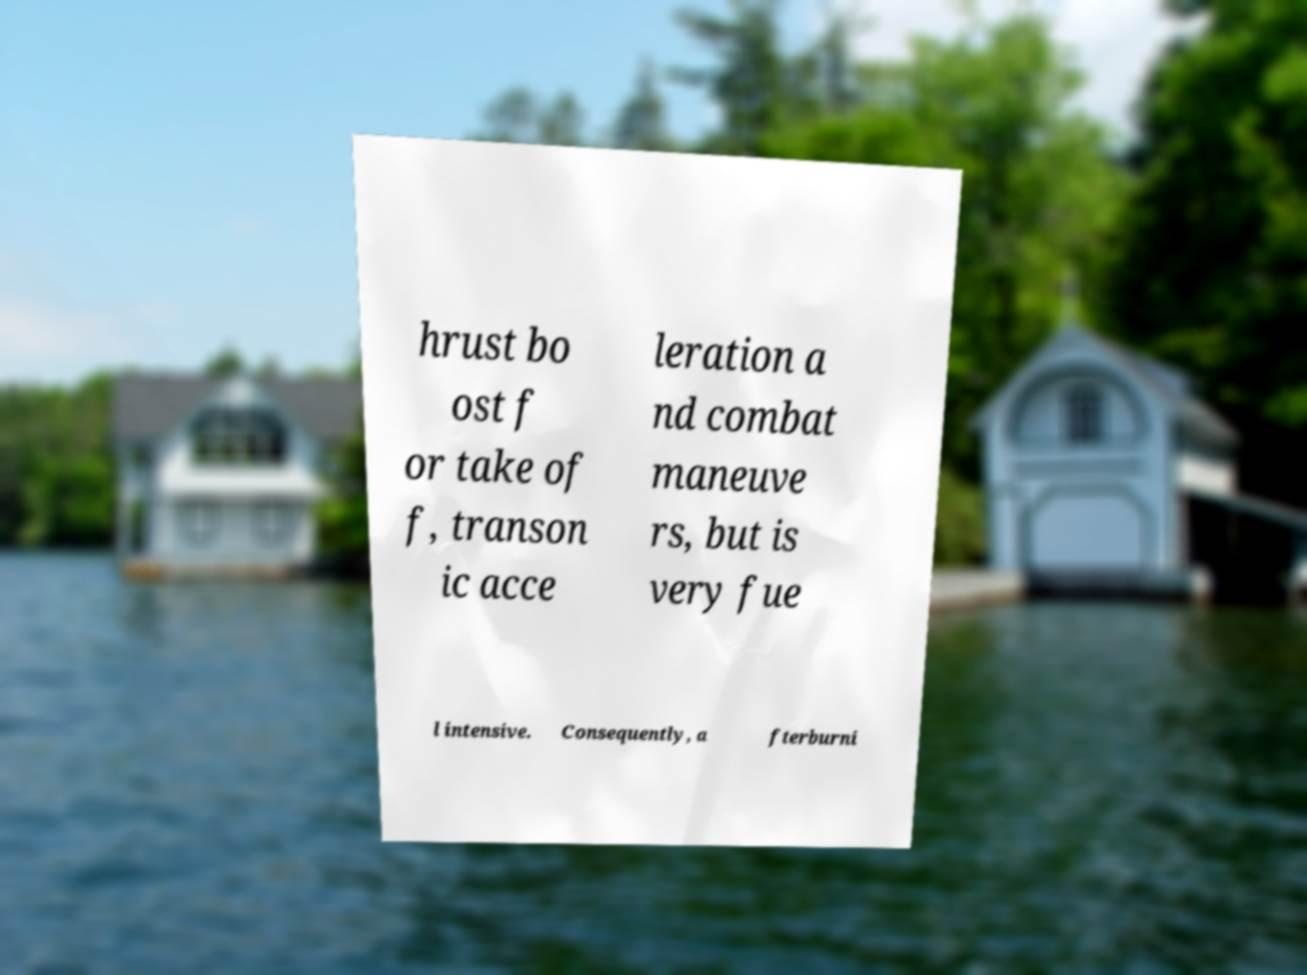Could you extract and type out the text from this image? hrust bo ost f or take of f, transon ic acce leration a nd combat maneuve rs, but is very fue l intensive. Consequently, a fterburni 